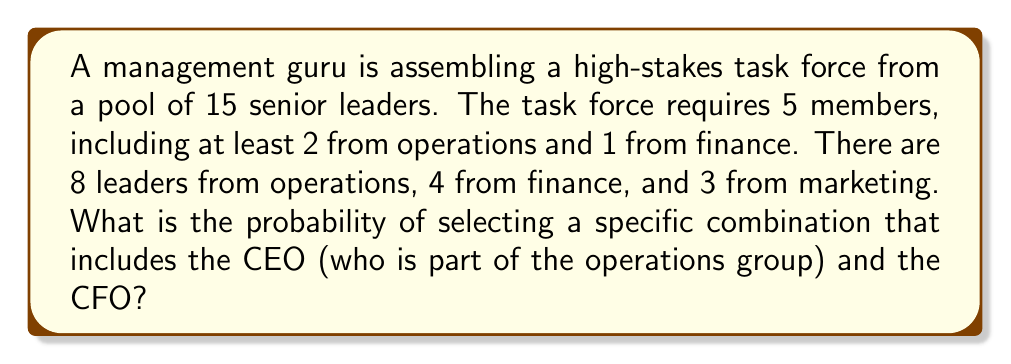Help me with this question. Let's approach this step-by-step:

1) First, we need to calculate the total number of ways to select 5 leaders from 15, which is a combination:

   $$\binom{15}{5} = \frac{15!}{5!(15-5)!} = 3003$$

2) Now, for the specific combination we want:
   - The CEO (operations) and CFO (finance) are already selected
   - We need at least one more from operations (we have 7 left to choose from)
   - We need 2 more positions filled from any department

3) Let's count the valid combinations:
   - Choose 1 more from operations: $\binom{7}{1}$
   - Choose 2 from the remaining 12 (7 operations + 3 finance + 3 marketing): $\binom{12}{2}$

4) Total valid combinations:

   $$\binom{7}{1} \times \binom{12}{2} = 7 \times 66 = 462$$

5) The probability is the number of favorable outcomes divided by the total number of possible outcomes:

   $$P = \frac{462}{3003} = \frac{154}{1001} \approx 0.1538$$
Answer: $\frac{154}{1001}$ 